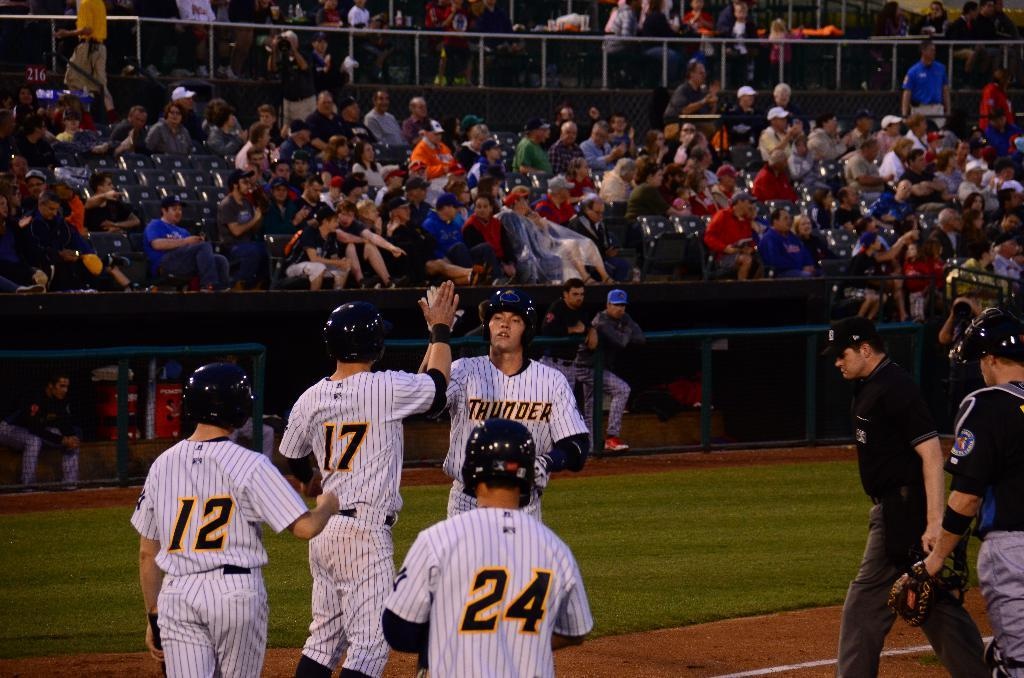<image>
Describe the image concisely. The team Thunder is playing on the field. 